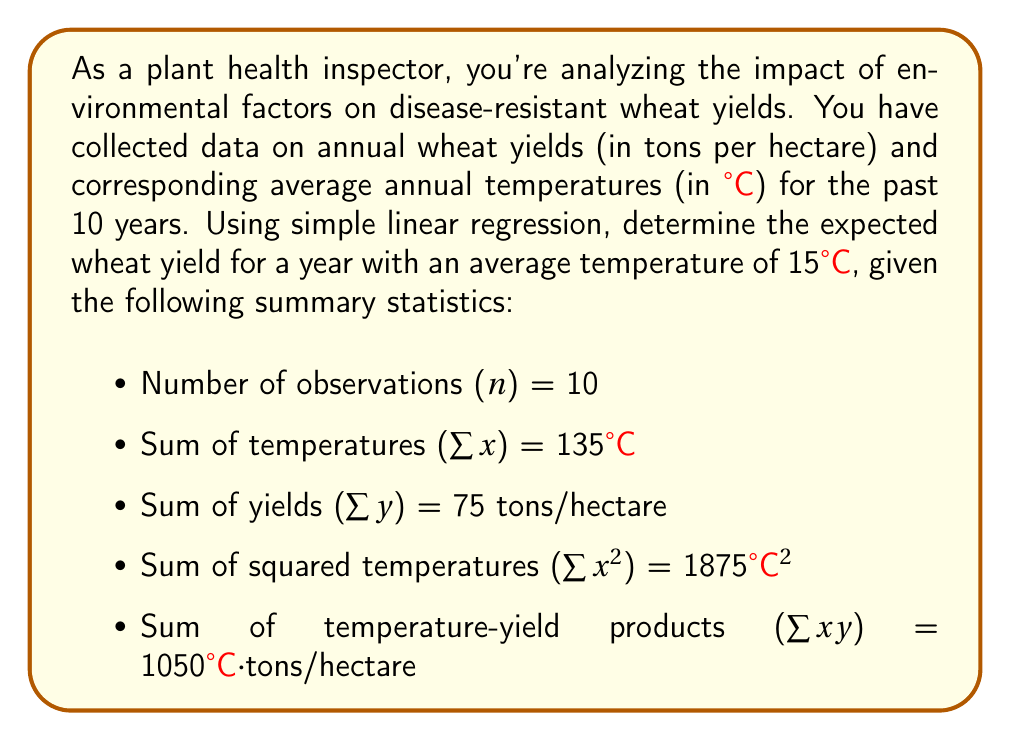Provide a solution to this math problem. To solve this problem, we'll use simple linear regression to model the relationship between temperature (x) and wheat yield (y). The steps are as follows:

1. Calculate the slope (b) of the regression line:
   
   $$b = \frac{n\sum xy - \sum x \sum y}{n\sum x^2 - (\sum x)^2}$$

2. Calculate the y-intercept (a) of the regression line:
   
   $$a = \frac{\sum y - b\sum x}{n}$$

3. Use the regression equation $y = a + bx$ to predict the yield for a given temperature.

Step 1: Calculate the slope (b)

$$\begin{aligned}
b &= \frac{10(1050) - 135(75)}{10(1875) - 135^2} \\
&= \frac{10500 - 10125}{18750 - 18225} \\
&= \frac{375}{525} \\
&= \frac{5}{7} \approx 0.7143
\end{aligned}$$

Step 2: Calculate the y-intercept (a)

First, we need the means of x and y:
$$\bar{x} = \frac{\sum x}{n} = \frac{135}{10} = 13.5$$
$$\bar{y} = \frac{\sum y}{n} = \frac{75}{10} = 7.5$$

Now we can calculate a:
$$\begin{aligned}
a &= \bar{y} - b\bar{x} \\
&= 7.5 - 0.7143(13.5) \\
&= 7.5 - 9.6429 \\
&= -2.1429
\end{aligned}$$

Step 3: Use the regression equation to predict yield at 15°C

$$\begin{aligned}
y &= a + bx \\
&= -2.1429 + 0.7143(15) \\
&= -2.1429 + 10.7145 \\
&= 8.5716
\end{aligned}$$
Answer: The expected wheat yield for a year with an average temperature of 15°C is approximately 8.57 tons per hectare. 